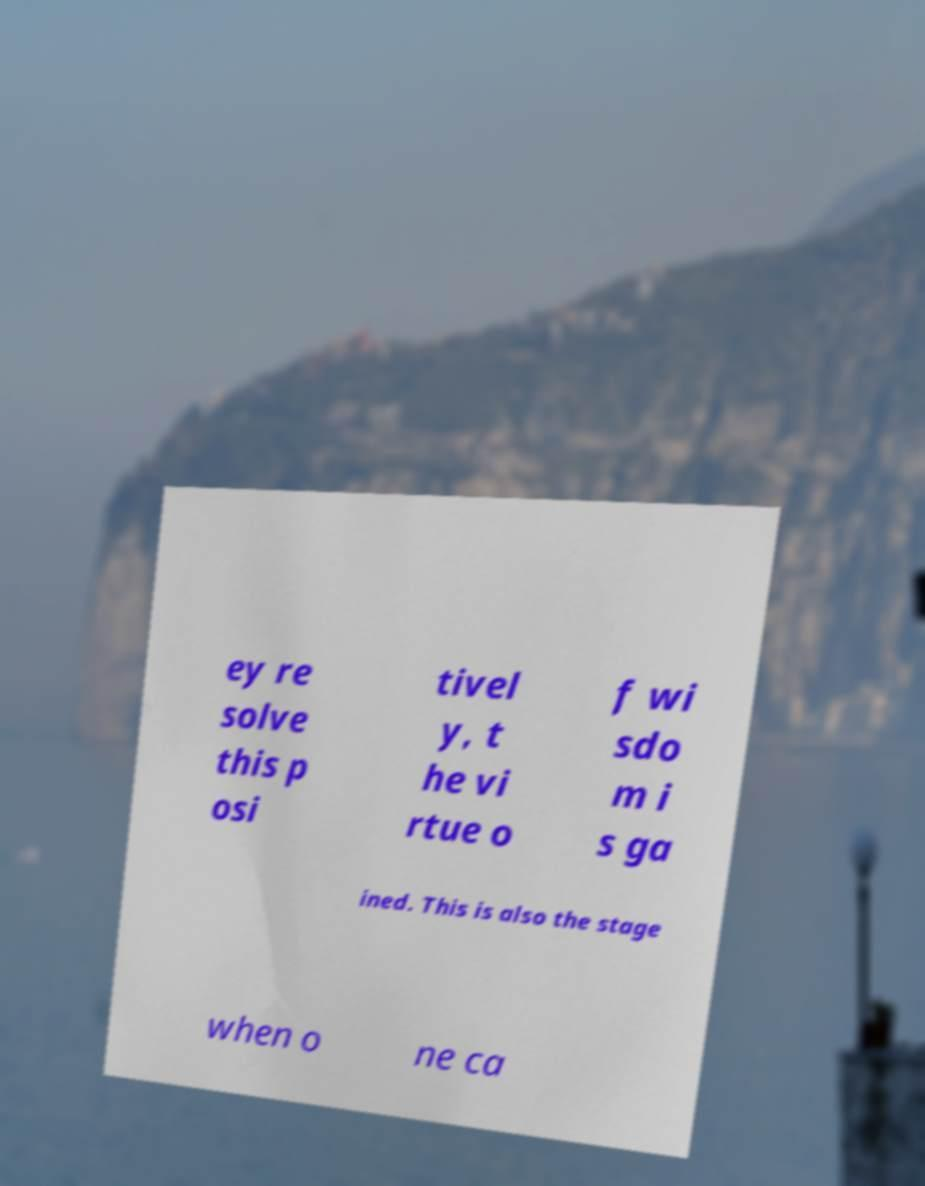Please read and relay the text visible in this image. What does it say? ey re solve this p osi tivel y, t he vi rtue o f wi sdo m i s ga ined. This is also the stage when o ne ca 